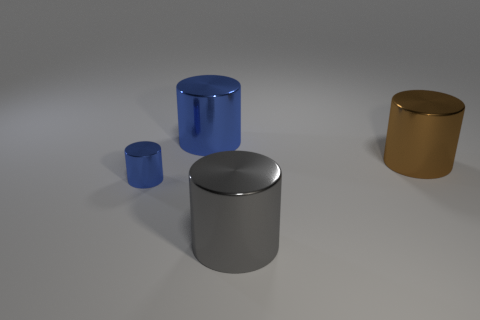Add 3 red spheres. How many objects exist? 7 Subtract 0 red cylinders. How many objects are left? 4 Subtract all blue metal objects. Subtract all big green metallic objects. How many objects are left? 2 Add 2 shiny cylinders. How many shiny cylinders are left? 6 Add 3 green rubber blocks. How many green rubber blocks exist? 3 